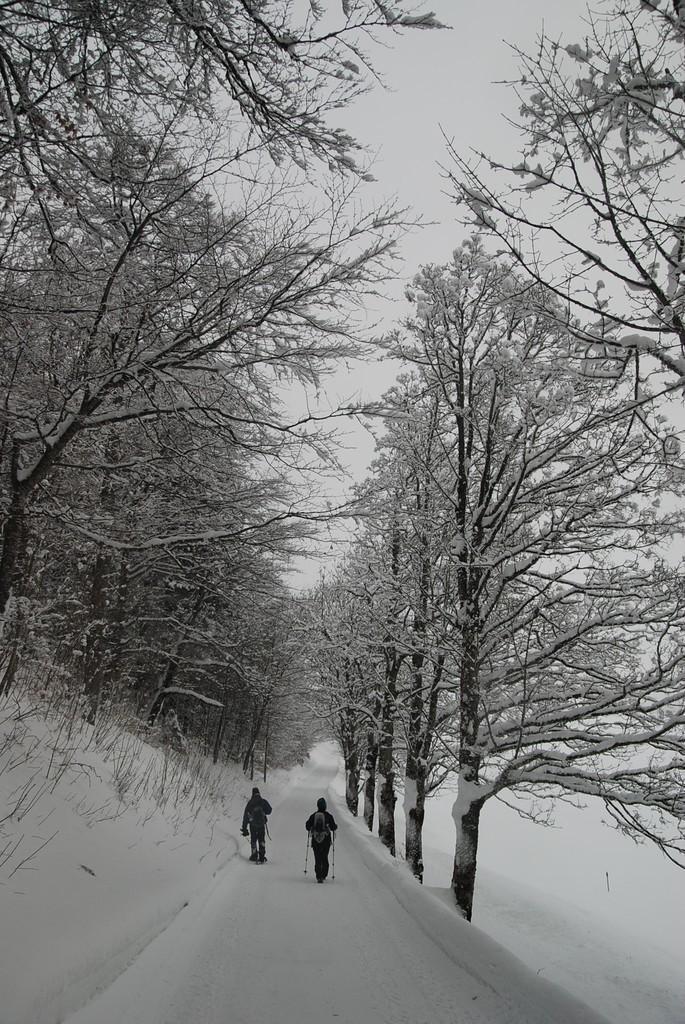Describe this image in one or two sentences. In the image there are two persons walking in the middle of path with trees on either side of it on the snow land and above its sky. 